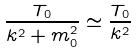Convert formula to latex. <formula><loc_0><loc_0><loc_500><loc_500>\frac { T _ { 0 } } { { k } ^ { 2 } + m _ { 0 } ^ { 2 } } \simeq \frac { T _ { 0 } } { { k } ^ { 2 } }</formula> 